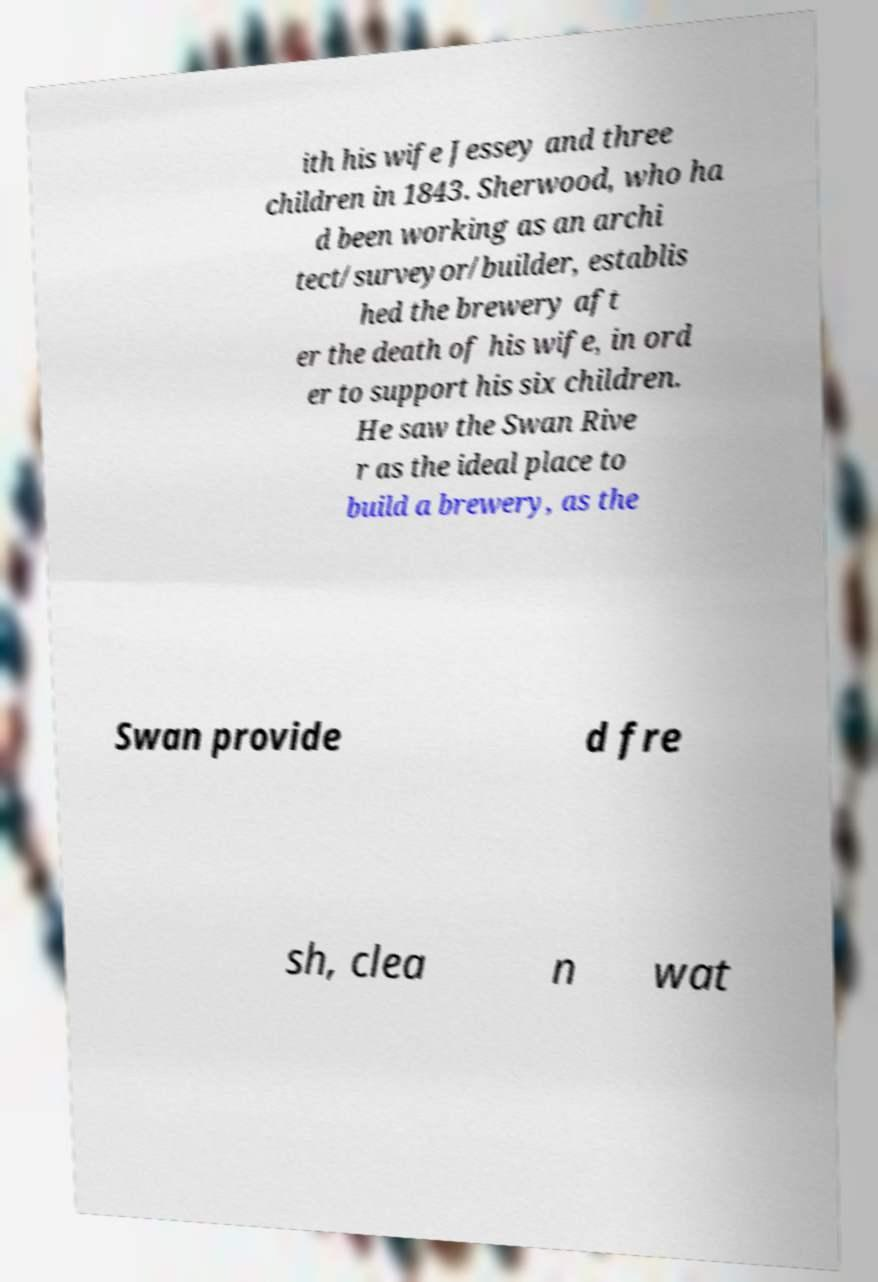Could you assist in decoding the text presented in this image and type it out clearly? ith his wife Jessey and three children in 1843. Sherwood, who ha d been working as an archi tect/surveyor/builder, establis hed the brewery aft er the death of his wife, in ord er to support his six children. He saw the Swan Rive r as the ideal place to build a brewery, as the Swan provide d fre sh, clea n wat 